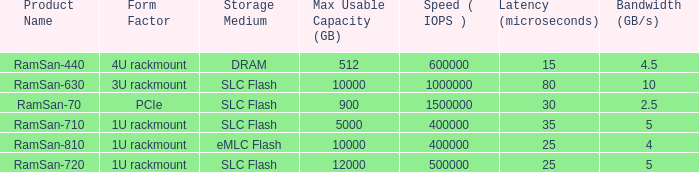What is the Input/output operations per second for the emlc flash? 400000.0. 